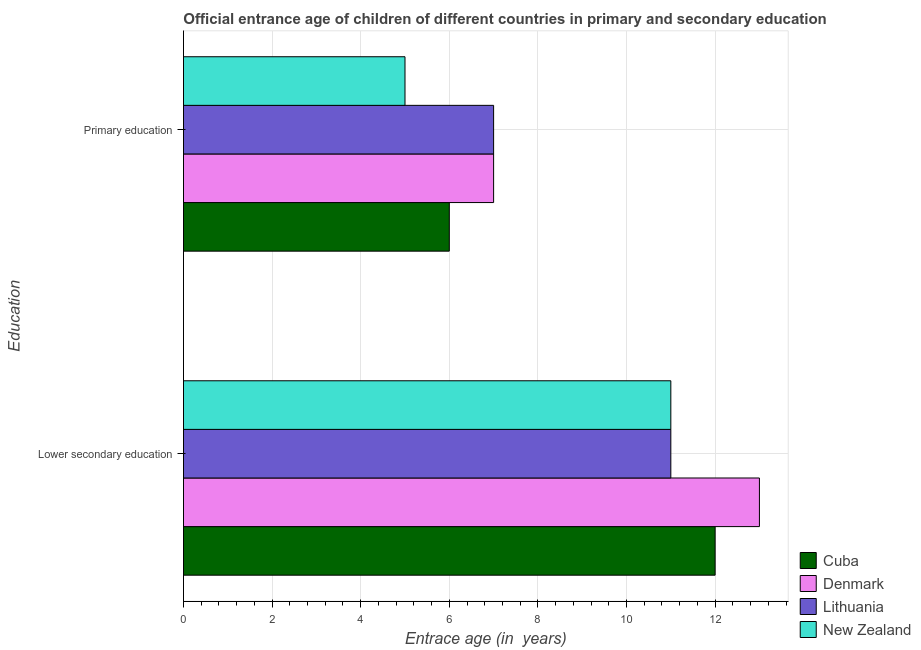How many groups of bars are there?
Your answer should be compact. 2. Are the number of bars on each tick of the Y-axis equal?
Provide a succinct answer. Yes. How many bars are there on the 1st tick from the top?
Your answer should be very brief. 4. How many bars are there on the 1st tick from the bottom?
Provide a succinct answer. 4. What is the entrance age of children in lower secondary education in Cuba?
Offer a terse response. 12. Across all countries, what is the maximum entrance age of chiildren in primary education?
Offer a terse response. 7. Across all countries, what is the minimum entrance age of children in lower secondary education?
Ensure brevity in your answer.  11. In which country was the entrance age of chiildren in primary education minimum?
Your answer should be compact. New Zealand. What is the total entrance age of children in lower secondary education in the graph?
Give a very brief answer. 47. What is the difference between the entrance age of children in lower secondary education in Cuba and that in New Zealand?
Provide a succinct answer. 1. What is the difference between the entrance age of children in lower secondary education in New Zealand and the entrance age of chiildren in primary education in Cuba?
Keep it short and to the point. 5. What is the average entrance age of chiildren in primary education per country?
Your response must be concise. 6.25. What is the difference between the entrance age of chiildren in primary education and entrance age of children in lower secondary education in Cuba?
Ensure brevity in your answer.  -6. What is the ratio of the entrance age of chiildren in primary education in Denmark to that in Cuba?
Your answer should be very brief. 1.17. In how many countries, is the entrance age of children in lower secondary education greater than the average entrance age of children in lower secondary education taken over all countries?
Ensure brevity in your answer.  2. What does the 2nd bar from the top in Lower secondary education represents?
Ensure brevity in your answer.  Lithuania. What does the 3rd bar from the bottom in Primary education represents?
Give a very brief answer. Lithuania. Are all the bars in the graph horizontal?
Keep it short and to the point. Yes. How many countries are there in the graph?
Provide a short and direct response. 4. Does the graph contain any zero values?
Provide a short and direct response. No. What is the title of the graph?
Make the answer very short. Official entrance age of children of different countries in primary and secondary education. What is the label or title of the X-axis?
Make the answer very short. Entrace age (in  years). What is the label or title of the Y-axis?
Keep it short and to the point. Education. What is the Entrace age (in  years) of Lithuania in Lower secondary education?
Keep it short and to the point. 11. What is the Entrace age (in  years) in New Zealand in Lower secondary education?
Keep it short and to the point. 11. What is the Entrace age (in  years) of Cuba in Primary education?
Your answer should be very brief. 6. What is the Entrace age (in  years) of Lithuania in Primary education?
Provide a succinct answer. 7. What is the Entrace age (in  years) of New Zealand in Primary education?
Give a very brief answer. 5. Across all Education, what is the maximum Entrace age (in  years) in Denmark?
Offer a very short reply. 13. Across all Education, what is the maximum Entrace age (in  years) in Lithuania?
Ensure brevity in your answer.  11. Across all Education, what is the minimum Entrace age (in  years) in Denmark?
Give a very brief answer. 7. Across all Education, what is the minimum Entrace age (in  years) of New Zealand?
Keep it short and to the point. 5. What is the total Entrace age (in  years) in Cuba in the graph?
Ensure brevity in your answer.  18. What is the difference between the Entrace age (in  years) in Lithuania in Lower secondary education and that in Primary education?
Make the answer very short. 4. What is the difference between the Entrace age (in  years) in New Zealand in Lower secondary education and that in Primary education?
Keep it short and to the point. 6. What is the difference between the Entrace age (in  years) of Cuba in Lower secondary education and the Entrace age (in  years) of Denmark in Primary education?
Provide a short and direct response. 5. What is the difference between the Entrace age (in  years) in Cuba in Lower secondary education and the Entrace age (in  years) in New Zealand in Primary education?
Your answer should be very brief. 7. What is the difference between the Entrace age (in  years) of Denmark in Lower secondary education and the Entrace age (in  years) of New Zealand in Primary education?
Keep it short and to the point. 8. What is the average Entrace age (in  years) in Cuba per Education?
Keep it short and to the point. 9. What is the average Entrace age (in  years) in Denmark per Education?
Your response must be concise. 10. What is the average Entrace age (in  years) of New Zealand per Education?
Offer a very short reply. 8. What is the difference between the Entrace age (in  years) of Cuba and Entrace age (in  years) of Denmark in Lower secondary education?
Offer a very short reply. -1. What is the difference between the Entrace age (in  years) of Cuba and Entrace age (in  years) of Lithuania in Lower secondary education?
Give a very brief answer. 1. What is the difference between the Entrace age (in  years) of Cuba and Entrace age (in  years) of New Zealand in Lower secondary education?
Keep it short and to the point. 1. What is the difference between the Entrace age (in  years) of Lithuania and Entrace age (in  years) of New Zealand in Lower secondary education?
Give a very brief answer. 0. What is the difference between the Entrace age (in  years) of Cuba and Entrace age (in  years) of Lithuania in Primary education?
Offer a very short reply. -1. What is the difference between the Entrace age (in  years) in Denmark and Entrace age (in  years) in Lithuania in Primary education?
Give a very brief answer. 0. What is the difference between the Entrace age (in  years) of Denmark and Entrace age (in  years) of New Zealand in Primary education?
Provide a short and direct response. 2. What is the difference between the Entrace age (in  years) of Lithuania and Entrace age (in  years) of New Zealand in Primary education?
Make the answer very short. 2. What is the ratio of the Entrace age (in  years) in Denmark in Lower secondary education to that in Primary education?
Keep it short and to the point. 1.86. What is the ratio of the Entrace age (in  years) of Lithuania in Lower secondary education to that in Primary education?
Give a very brief answer. 1.57. What is the ratio of the Entrace age (in  years) in New Zealand in Lower secondary education to that in Primary education?
Give a very brief answer. 2.2. What is the difference between the highest and the second highest Entrace age (in  years) in Cuba?
Offer a terse response. 6. What is the difference between the highest and the second highest Entrace age (in  years) in New Zealand?
Provide a succinct answer. 6. What is the difference between the highest and the lowest Entrace age (in  years) in Denmark?
Make the answer very short. 6. What is the difference between the highest and the lowest Entrace age (in  years) in Lithuania?
Offer a terse response. 4. 